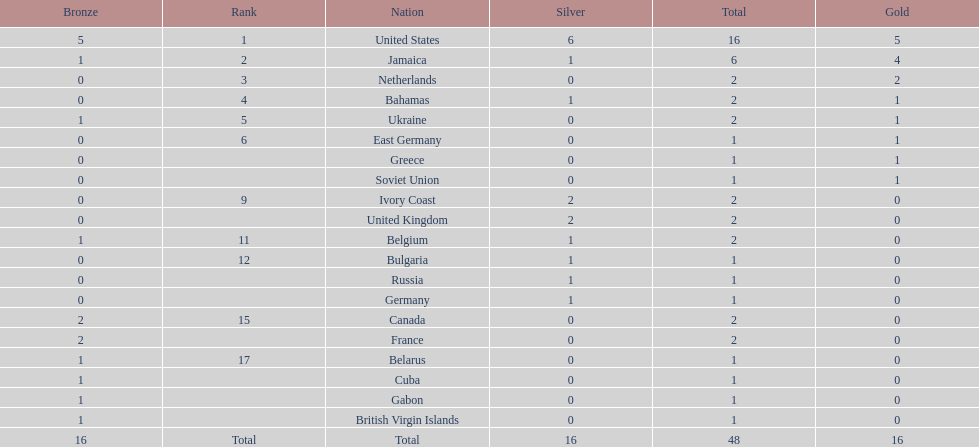What is the overall count of gold medals secured by jamaica? 4. 